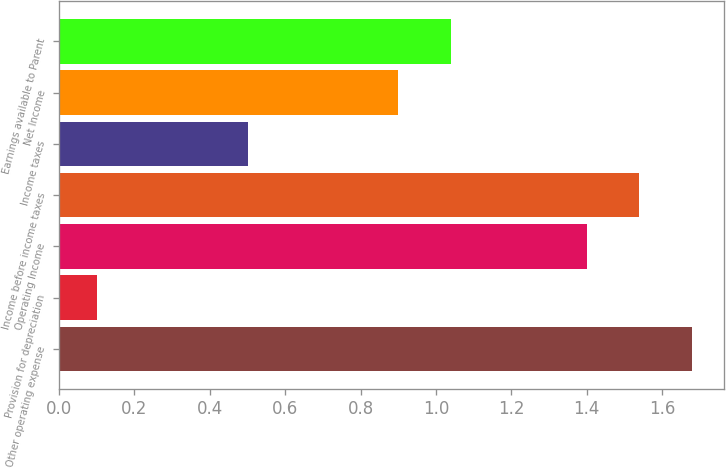Convert chart to OTSL. <chart><loc_0><loc_0><loc_500><loc_500><bar_chart><fcel>Other operating expense<fcel>Provision for depreciation<fcel>Operating Income<fcel>Income before income taxes<fcel>Income taxes<fcel>Net Income<fcel>Earnings available to Parent<nl><fcel>1.68<fcel>0.1<fcel>1.4<fcel>1.54<fcel>0.5<fcel>0.9<fcel>1.04<nl></chart> 